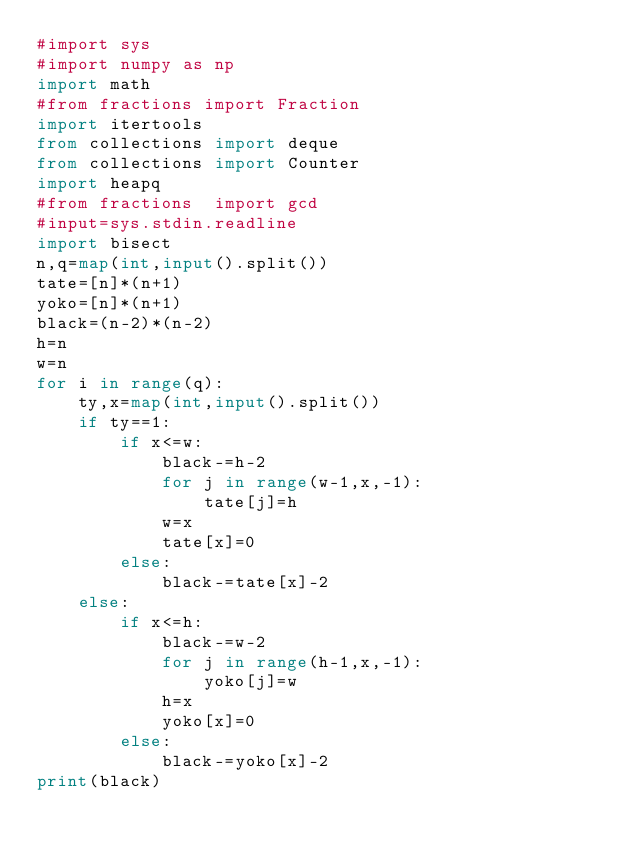Convert code to text. <code><loc_0><loc_0><loc_500><loc_500><_Python_>#import sys
#import numpy as np
import math
#from fractions import Fraction
import itertools
from collections import deque
from collections import Counter
import heapq
#from fractions  import gcd
#input=sys.stdin.readline
import bisect
n,q=map(int,input().split())
tate=[n]*(n+1)
yoko=[n]*(n+1)
black=(n-2)*(n-2)
h=n
w=n
for i in range(q):
    ty,x=map(int,input().split())
    if ty==1:
        if x<=w:
            black-=h-2
            for j in range(w-1,x,-1):
                tate[j]=h   
            w=x
            tate[x]=0
        else:
            black-=tate[x]-2
    else:
        if x<=h:
            black-=w-2
            for j in range(h-1,x,-1):
                yoko[j]=w
            h=x
            yoko[x]=0
        else:
            black-=yoko[x]-2
print(black)</code> 